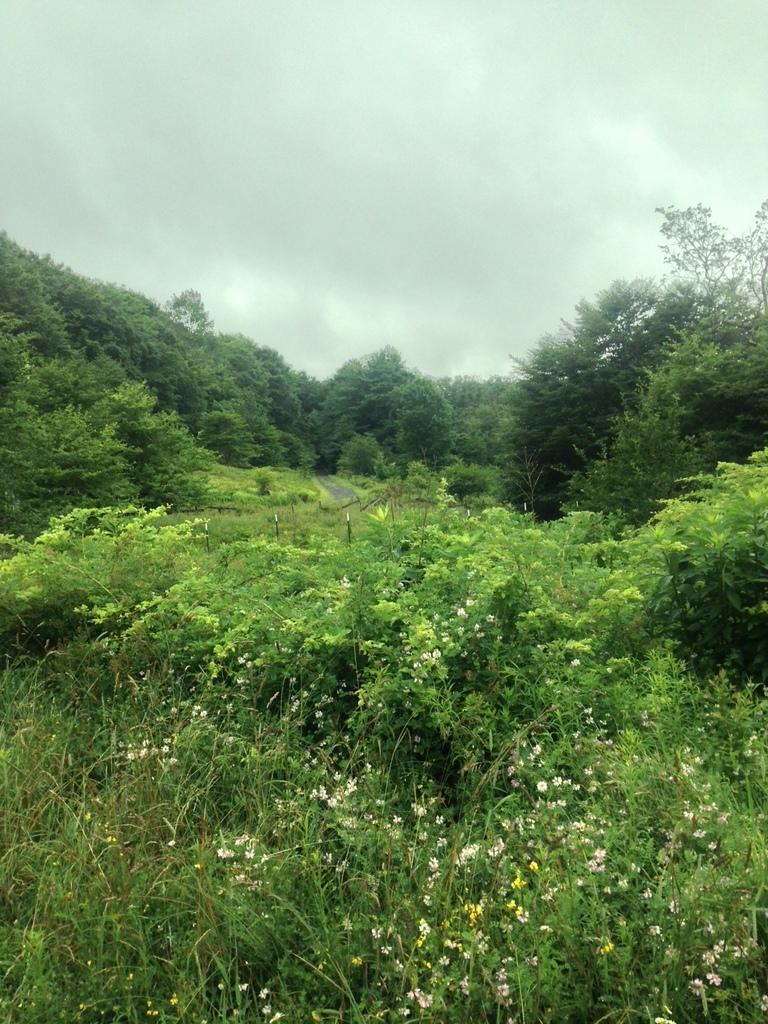What type of vegetation can be seen in the image? There are trees in the image. What else can be seen on the ground in the image? There is grass in the image. What is visible in the background of the image? The sky is visible in the image. What can be observed in the sky? Clouds are present in the sky. What type of soda is being poured in the image? There is no soda present in the image; it features trees, grass, sky, and clouds. 